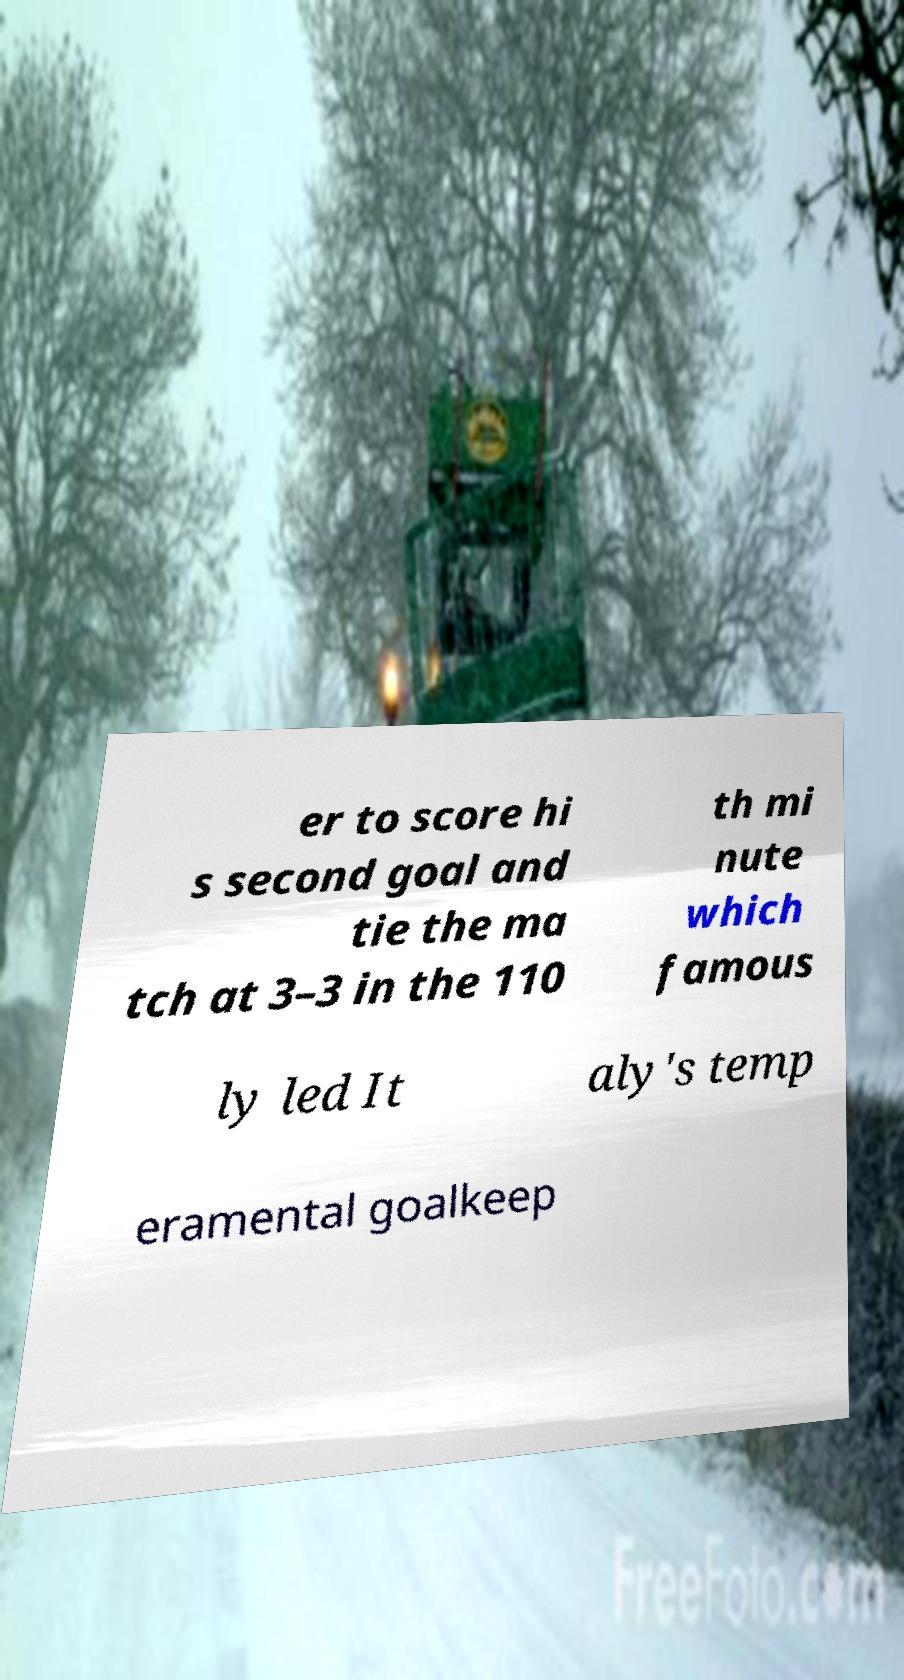Please read and relay the text visible in this image. What does it say? er to score hi s second goal and tie the ma tch at 3–3 in the 110 th mi nute which famous ly led It aly's temp eramental goalkeep 